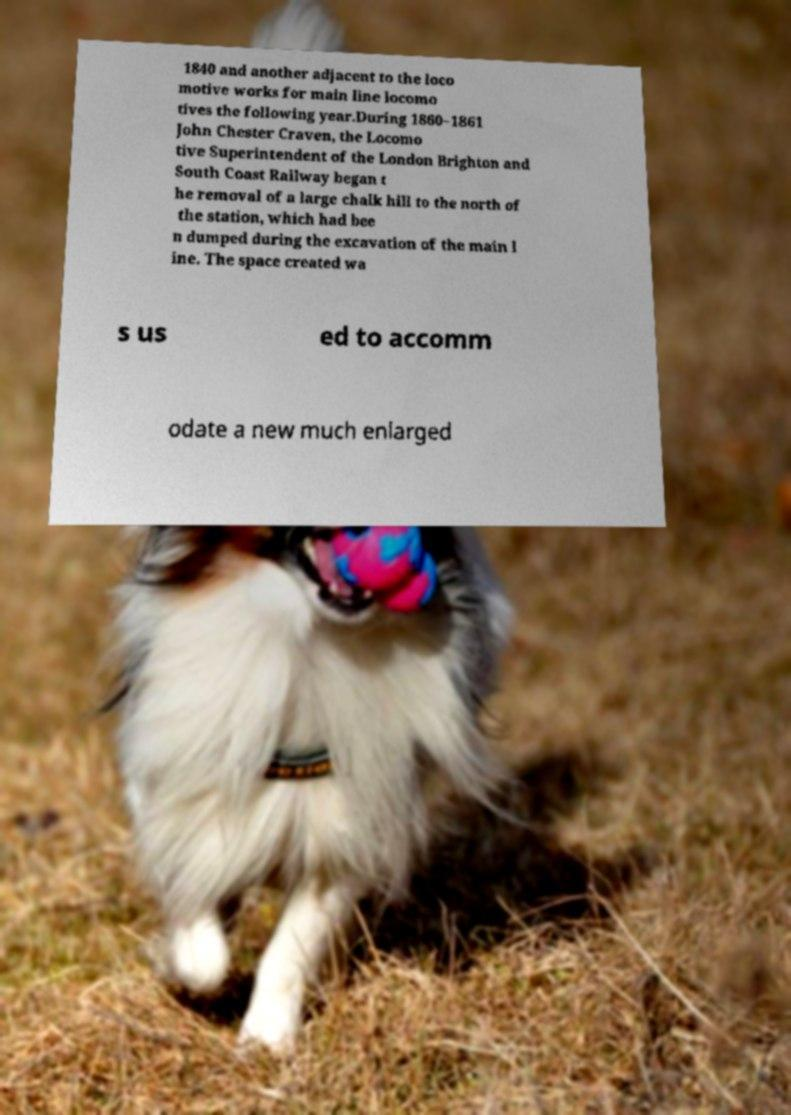Please read and relay the text visible in this image. What does it say? 1840 and another adjacent to the loco motive works for main line locomo tives the following year.During 1860–1861 John Chester Craven, the Locomo tive Superintendent of the London Brighton and South Coast Railway began t he removal of a large chalk hill to the north of the station, which had bee n dumped during the excavation of the main l ine. The space created wa s us ed to accomm odate a new much enlarged 